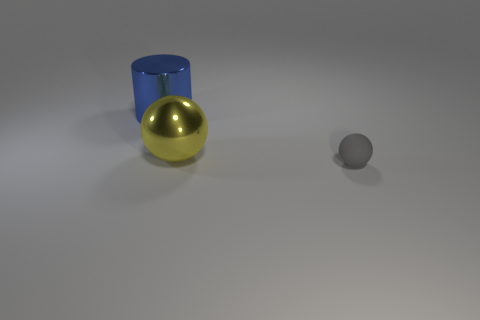Add 3 balls. How many objects exist? 6 Subtract all cylinders. How many objects are left? 2 Add 3 gray objects. How many gray objects are left? 4 Add 1 gray cubes. How many gray cubes exist? 1 Subtract 0 cyan spheres. How many objects are left? 3 Subtract all blue shiny balls. Subtract all cylinders. How many objects are left? 2 